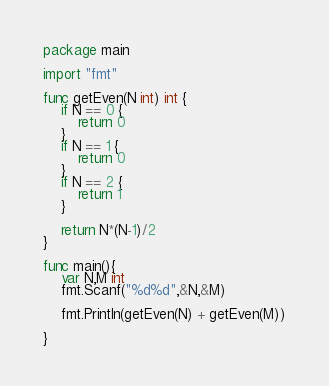<code> <loc_0><loc_0><loc_500><loc_500><_Go_>package main

import "fmt"

func getEven(N int) int {
	if N == 0 {
		return 0
	}
	if N == 1 {
		return 0
	}
	if N == 2 {
		return 1
	}

	return N*(N-1)/2
}

func main(){
	var N,M int
	fmt.Scanf("%d%d",&N,&M)

	fmt.Println(getEven(N) + getEven(M))

}
</code> 